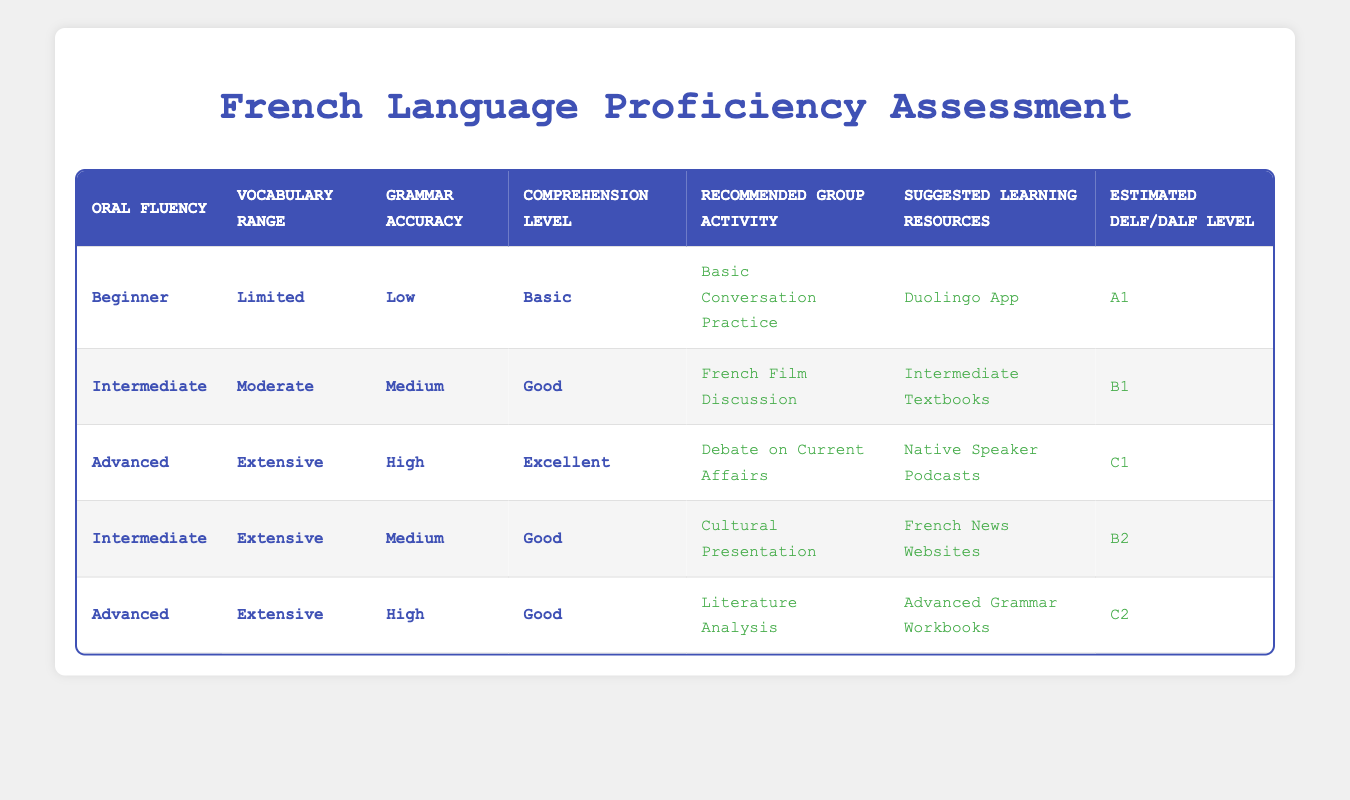What group activity is recommended for someone with Intermediate Oral Fluency and a Moderate Vocabulary Range? According to the table, if someone has Intermediate Oral Fluency and a Moderate Vocabulary Range, they fall into the second row, which recommends "French Film Discussion" as the group activity.
Answer: French Film Discussion What is the suggested learning resource for a learner with Limited Vocabulary Range, Low Grammar Accuracy, and Basic Comprehension Level? The table shows that for a learner with Limited Vocabulary Range, Low Grammar Accuracy, and Basic Comprehension Level, the recommended actions are "Basic Conversation Practice" and "Duolingo App." Thus, "Duolingo App" is the suggested resource.
Answer: Duolingo App Is there a group activity recommended for someone with Advanced Oral Fluency and High Grammar Accuracy, but only a Good Comprehension Level? Yes, according to the table, individuals with Advanced Oral Fluency, High Grammar Accuracy, and a Good Comprehension Level are recommended to engage in "Literature Analysis."
Answer: Yes How many group activities require a vocabulary range of Extensive? The table indicates that there are three activities relevant to participants with an Extensive Vocabulary Range: "Debate on Current Affairs," "Cultural Presentation," and "Literature Analysis." Hence, the total is 3.
Answer: 3 For a learner suggested to use French News Websites, what is their estimated DELF/DALF level? The table associates the action "French News Websites" with the condition "Intermediate, Extensive, Medium, Good," which corresponds to an estimated DELF/DALF level of B2.
Answer: B2 What is the maximum DELF/DALF level associated with someone who is a Beginner? The table shows that even within the conditions for a Beginner (Limited Vocabulary Range, Low Grammar Accuracy, Basic Comprehension Level), the estimated DELF/DALF level is A1, which is the lowest level. Therefore, A1 is the maximum for Beginners.
Answer: A1 How does the group activity change from Intermediate to Advanced proficiency with a Moderate Vocabulary Range and Medium Grammar Accuracy? For Intermediate proficiency with a Moderate Vocabulary Range and Medium Grammar Accuracy, the recommended activity is "French Film Discussion." However, for Advanced proficiency, regardless of the vocabulary and grammar conditions, the recommended shift would be to "Debate on Current Affairs" if the comprehension is Excellent or remain at "Literature Analysis" if that maintains a Good understanding. Thus, there is a change in activities as proficiency rises.
Answer: French Film Discussion to Debate on Current Affairs or Literature Analysis Is there a difference in suggested learning resources between Intermediate and Advanced levels in the table? Yes, there is a difference in the suggested learning resources; for Intermediate learners, the resource is "Intermediate Textbooks," while for Advanced learners, it is either "Native Speaker Podcasts" or "Advanced Grammar Workbooks," indicating a shift towards more advanced materials as proficiency increases.
Answer: Yes 